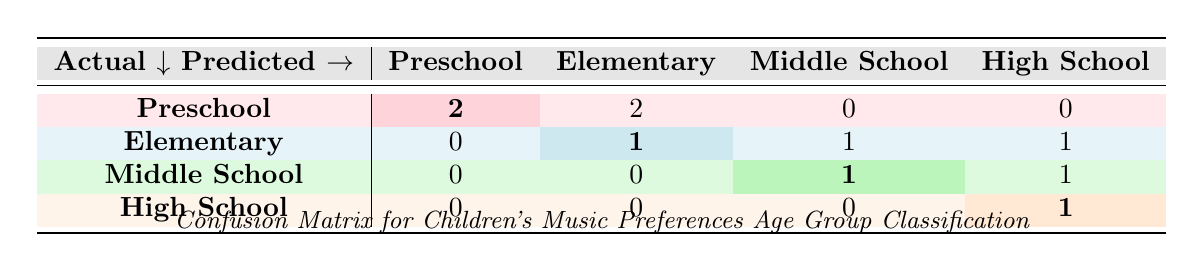What is the total number of predictions made for the Preschool age group? In the table, we look under the "Preschool" row, where we see two predictions were made for "Preschool" (2), two predictions for "Elementary" (0), and no predictions for "Middle School" or "High School" (0). Therefore, the total predictions for "Preschool" is 2.
Answer: 2 How many actual Preschool children were predicted as Elementary? To find this, we examine the "Elementary" row where one actual “Preschool” was incorrectly predicted as “Elementary” (2). Since the “Preschool” row has 2 predictions as "Elementary", that leads to just 1.
Answer: 2 What is the count of correct predictions for the High School age group? In the "High School" row, we see that there is 1 correct prediction where actual "High School" was predicted as "High School" (1). Hence, there is a count of 1 correct prediction for the High School group.
Answer: 1 Is there any age group with no correct predictions? Assessing each row, we see the “Elementary” and “Preschool” rows have correct predictions. However, all actual instances of "Middle School" & "High School" show discrepancies at least once. Thus, there’s no age group with no correct predictions since all have at least one correct.
Answer: No What is the percentage of incorrect predictions for the Middle School age group? For "Middle School," we found 2 predictions in total (1 correct, 1 incorrect). The total predictions were 1 (correct "Middle School") + 1 (incorrect "High School") = 2. Thus, the percentage of incorrect predictions is calculated as (1 incorrect/2 total) * 100 = 50%.
Answer: 50% If we add the predictions for Elementary and Middle School, how many incorrect predictions are there in total? The "Elementary" row indicates 1 correct and 2 incorrect predictions (1 to “Middle School” and 1 to “High School”). The "Middle School" row indicates 1 correct ("Middle School") and 1 incorrect (to “High School”). Thus, adding the incorrect predictions from each group gives 2 (Elementary) + 1 (Middle School) = 3.
Answer: 3 Which age group has the most correct predictions? By analyzing the rows, "Preschool" holds the highest count of 2 correct predictions, thus marking "Preschool" as the age group with the most correct predictions followed by Elementary and others below that.
Answer: Preschool Are there equal misclassifications for Elementary and Middle School age groups? Upon evaluating the “Elementary” and “Middle School” rows, you have "Elementary" showing 2 misclassifications, while “Middle School” shows 1 misclassification pointing towards two other age groups. Hence, they do not possess equal misclassifications.
Answer: No 